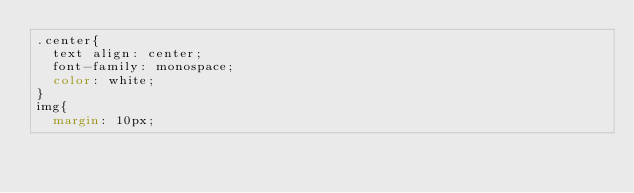Convert code to text. <code><loc_0><loc_0><loc_500><loc_500><_CSS_>.center{
  text align: center;
  font-family: monospace;
  color: white;
}
img{
  margin: 10px;</code> 